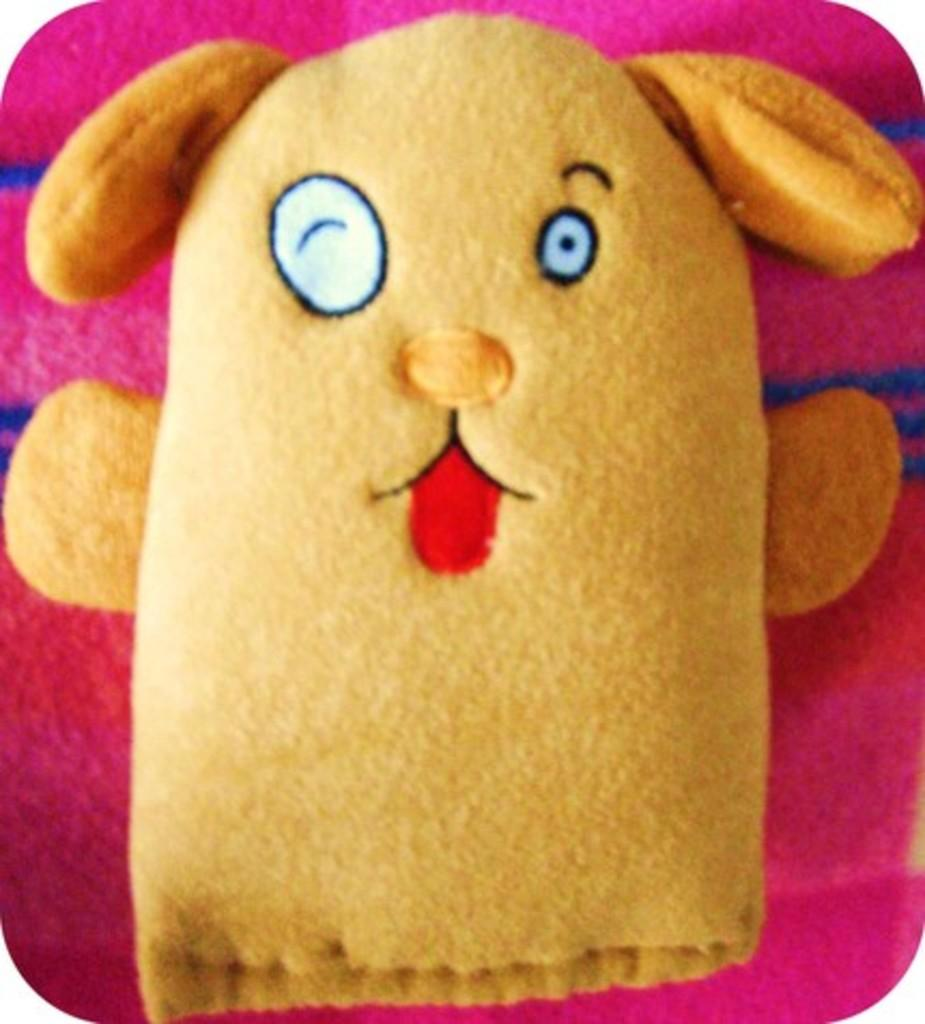What is present in the image related to headwear? There is a cap in the image. What is the color of the cloth on the cap? The cap has pink color cloth. What type of glue is used to attach the cap to the person's head in the image? There is no glue present in the image, and the cap is not attached to anyone's head. How many forks can be seen in the image? There are no forks present in the image. 